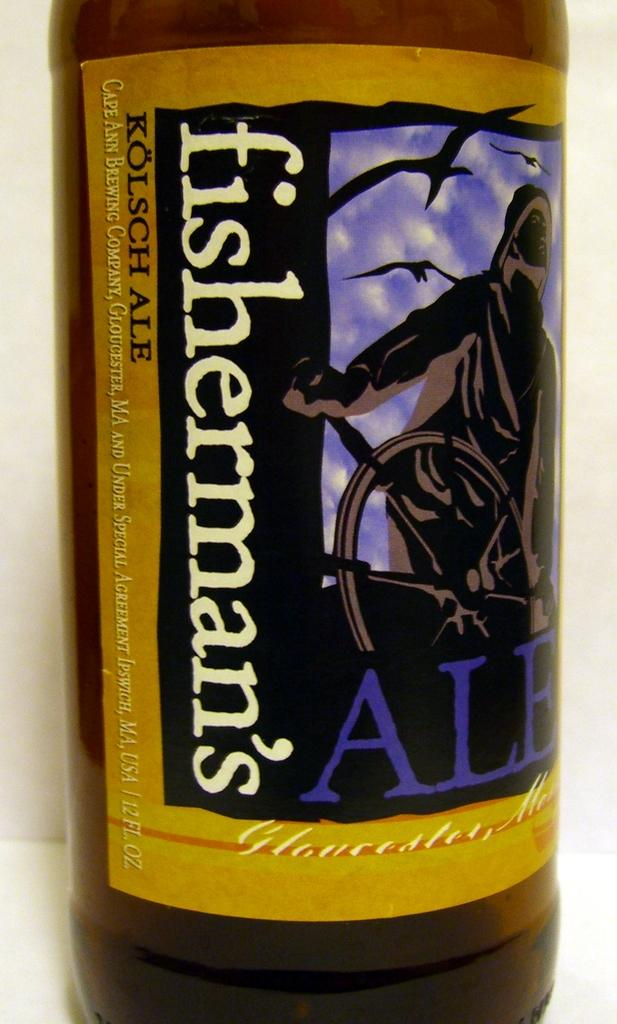<image>
Relay a brief, clear account of the picture shown. A bottle of beer that says fisherman's Ale. 